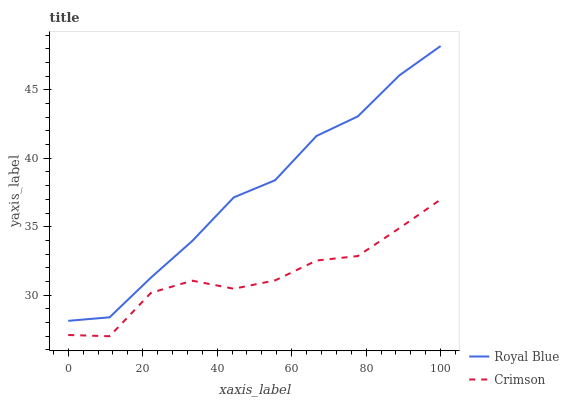Does Crimson have the minimum area under the curve?
Answer yes or no. Yes. Does Royal Blue have the maximum area under the curve?
Answer yes or no. Yes. Does Royal Blue have the minimum area under the curve?
Answer yes or no. No. Is Royal Blue the smoothest?
Answer yes or no. Yes. Is Crimson the roughest?
Answer yes or no. Yes. Is Royal Blue the roughest?
Answer yes or no. No. Does Crimson have the lowest value?
Answer yes or no. Yes. Does Royal Blue have the lowest value?
Answer yes or no. No. Does Royal Blue have the highest value?
Answer yes or no. Yes. Is Crimson less than Royal Blue?
Answer yes or no. Yes. Is Royal Blue greater than Crimson?
Answer yes or no. Yes. Does Crimson intersect Royal Blue?
Answer yes or no. No. 